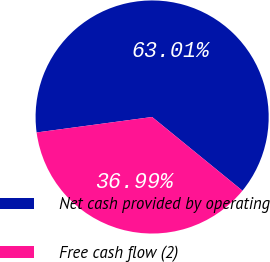Convert chart to OTSL. <chart><loc_0><loc_0><loc_500><loc_500><pie_chart><fcel>Net cash provided by operating<fcel>Free cash flow (2)<nl><fcel>63.01%<fcel>36.99%<nl></chart> 